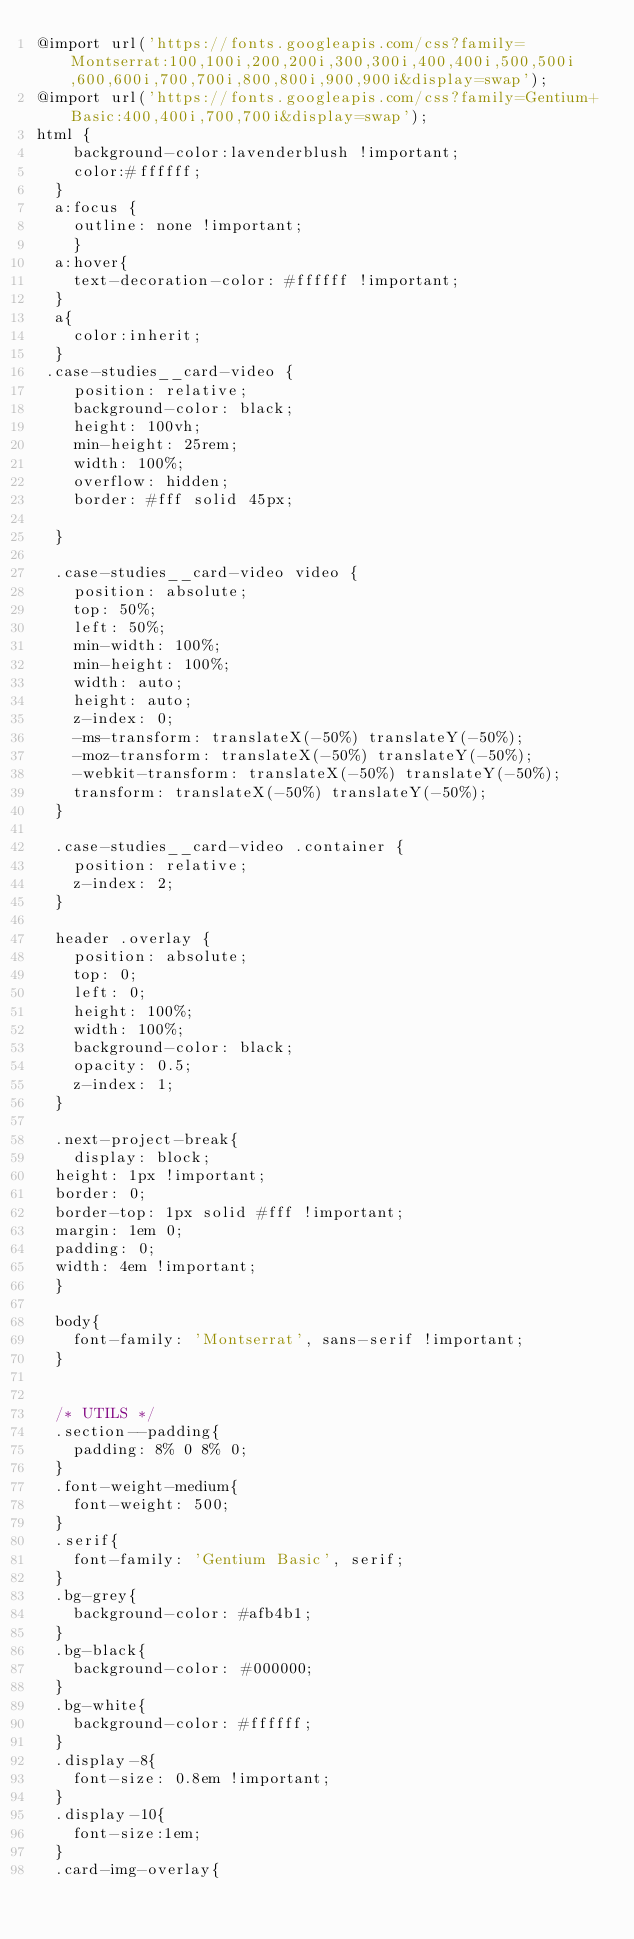Convert code to text. <code><loc_0><loc_0><loc_500><loc_500><_CSS_>@import url('https://fonts.googleapis.com/css?family=Montserrat:100,100i,200,200i,300,300i,400,400i,500,500i,600,600i,700,700i,800,800i,900,900i&display=swap');
@import url('https://fonts.googleapis.com/css?family=Gentium+Basic:400,400i,700,700i&display=swap');
html {
    background-color:lavenderblush !important;
    color:#ffffff;
  }
  a:focus {
    outline: none !important;
    }
  a:hover{
    text-decoration-color: #ffffff !important; 
  }
  a{
    color:inherit;
  }
 .case-studies__card-video {
    position: relative;
    background-color: black;
    height: 100vh;
    min-height: 25rem;
    width: 100%;
    overflow: hidden;
    border: #fff solid 45px;

  }
  
  .case-studies__card-video video {
    position: absolute;
    top: 50%;
    left: 50%;
    min-width: 100%;
    min-height: 100%;
    width: auto;
    height: auto;
    z-index: 0;
    -ms-transform: translateX(-50%) translateY(-50%);
    -moz-transform: translateX(-50%) translateY(-50%);
    -webkit-transform: translateX(-50%) translateY(-50%);
    transform: translateX(-50%) translateY(-50%);
  }
  
  .case-studies__card-video .container {
    position: relative;
    z-index: 2;
  }
  
  header .overlay {
    position: absolute;
    top: 0;
    left: 0;
    height: 100%;
    width: 100%;
    background-color: black;
    opacity: 0.5;
    z-index: 1;
  }

  .next-project-break{
    display: block;
  height: 1px !important;
  border: 0;
  border-top: 1px solid #fff !important;
  margin: 1em 0;
  padding: 0;
  width: 4em !important;
  }

  body{    
    font-family: 'Montserrat', sans-serif !important;
  }


  /* UTILS */
  .section--padding{
    padding: 8% 0 8% 0;
  }
  .font-weight-medium{
    font-weight: 500;
  }
  .serif{
    font-family: 'Gentium Basic', serif;
  }
  .bg-grey{
    background-color: #afb4b1;
  }
  .bg-black{
    background-color: #000000;
  }
  .bg-white{
    background-color: #ffffff; 
  }
  .display-8{
    font-size: 0.8em !important;
  }
  .display-10{
    font-size:1em;
  }
  .card-img-overlay{</code> 